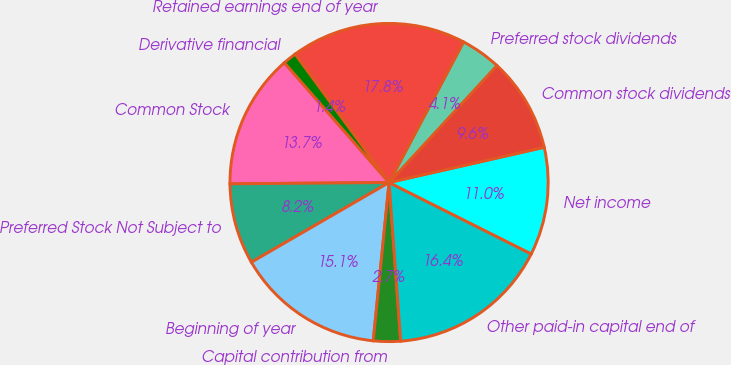Convert chart. <chart><loc_0><loc_0><loc_500><loc_500><pie_chart><fcel>Common Stock<fcel>Preferred Stock Not Subject to<fcel>Beginning of year<fcel>Capital contribution from<fcel>Other paid-in capital end of<fcel>Net income<fcel>Common stock dividends<fcel>Preferred stock dividends<fcel>Retained earnings end of year<fcel>Derivative financial<nl><fcel>13.7%<fcel>8.22%<fcel>15.06%<fcel>2.75%<fcel>16.43%<fcel>10.96%<fcel>9.59%<fcel>4.11%<fcel>17.8%<fcel>1.38%<nl></chart> 